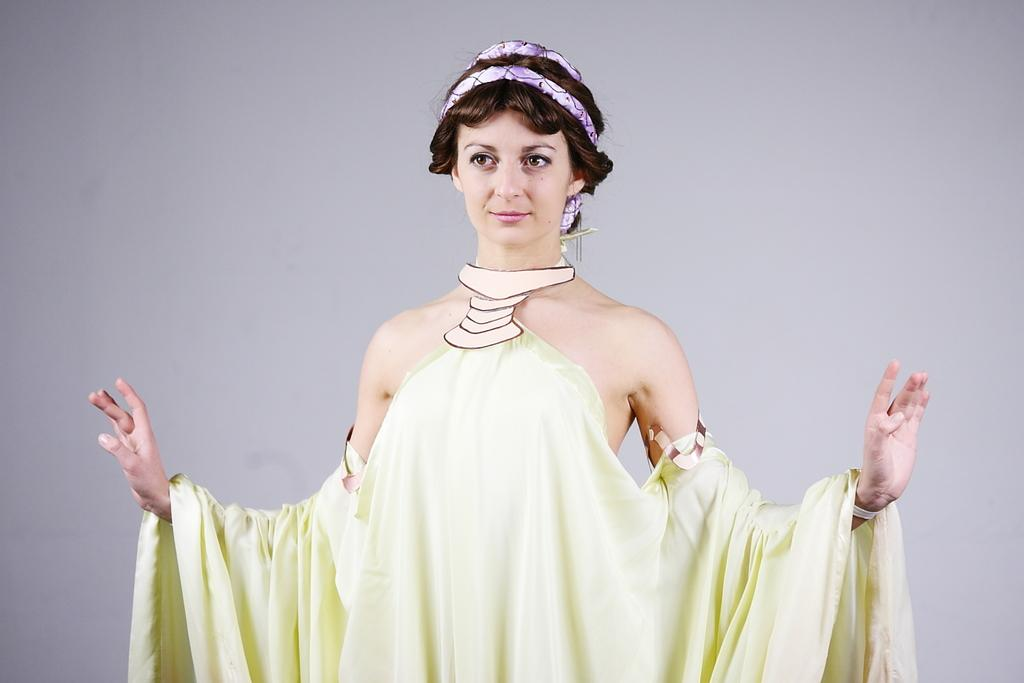What is the main subject of the image? There is a woman standing in the middle of the image. Can you describe the background of the image? There is a wall in the background of the image. What type of chess pieces can be seen on the table in the image? There is no table or chess pieces present in the image. Can you tell me how many dinosaurs are visible in the image? There are no dinosaurs present in the image. 